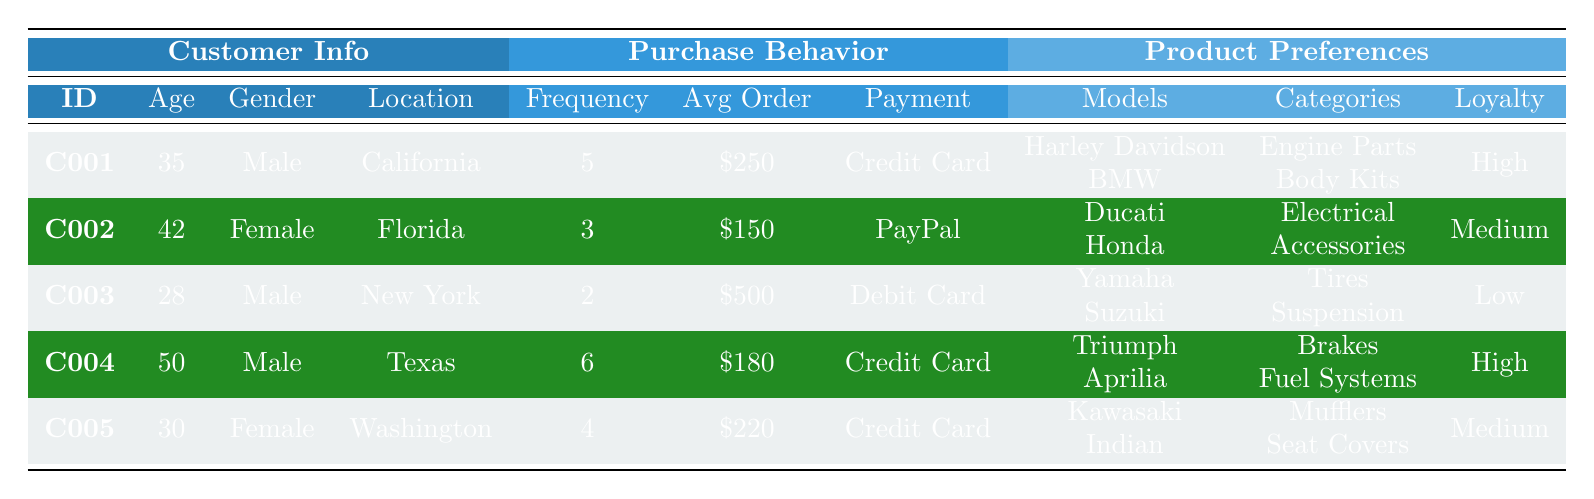What is the location of customer C003? By looking at the "Location" column and identifying the entry corresponding to "C003," we see that C003's location is "New York."
Answer: New York Which customer has the highest average order value? Reviewing the "Average Order Value" column, we find that C003 has the highest value of \$500 compared to others.
Answer: C003 How many customers prefer Credit Card as their payment method? Counting the entries in the "Preferred Payment Method" column, we find that C001, C004, and C005 all prefer Credit Card, totaling 3 customers.
Answer: 3 What is the range of ages among the customers? The ages listed are 28, 30, 35, 42, and 50. The highest age is 50 and the lowest age is 28. The range is 50 - 28 = 22.
Answer: 22 Do any female customers prefer PayPal as their payment method? Checking the "Gender" and "Preferred Payment Method" columns, C002 is the only female customer, and she prefers PayPal. So, yes, there is a female customer who prefers PayPal.
Answer: Yes What is the average purchase frequency among all customers? Adding the purchase frequencies (5 + 3 + 2 + 6 + 4) gives a total of 20. There are 5 customers, so the average is 20 / 5 = 4.
Answer: 4 Which preferred bike model is associated with the customer who has high brand loyalty and lives in Texas? Looking at the table, customer C004 is from Texas, has high brand loyalty, and prefers Triumph and Aprilia as bike models.
Answer: Triumph and Aprilia Is there a customer who prefers electrical parts and has a medium brand loyalty? C002 has medium brand loyalty and prefers electrical part categories, so the answer is yes.
Answer: Yes What is the total average order value for customers with high brand loyalty? The average order values for those with high brand loyalty (C001 and C004) are \$250 and \$180. Their total is \$250 + \$180 = \$430, and the average is \$430 / 2 = \$215.
Answer: \$215 How many customers prefer Honda among the preferred bike models? Only C002 prefers Honda as one of their bike models. Therefore, the number of customers who prefer Honda is 1.
Answer: 1 